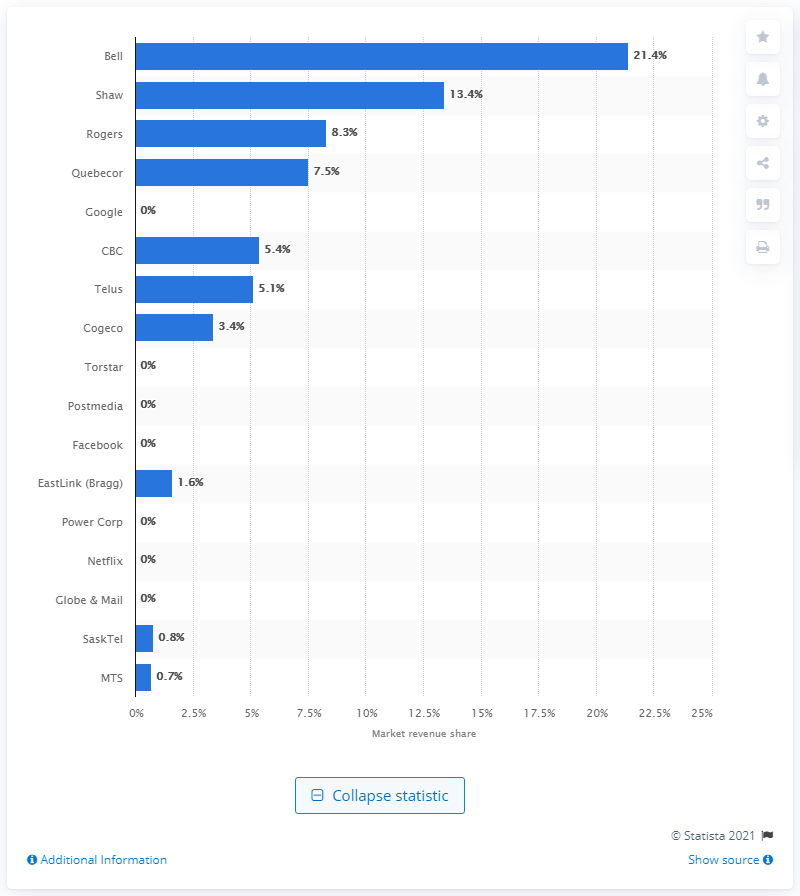Point out several critical features in this image. In 2015, Bell held a significant percentage of the Canadian media market, with a total market share of 21.4%. In 2015, Quebecor held approximately 7.5% of the Canadian media market. 